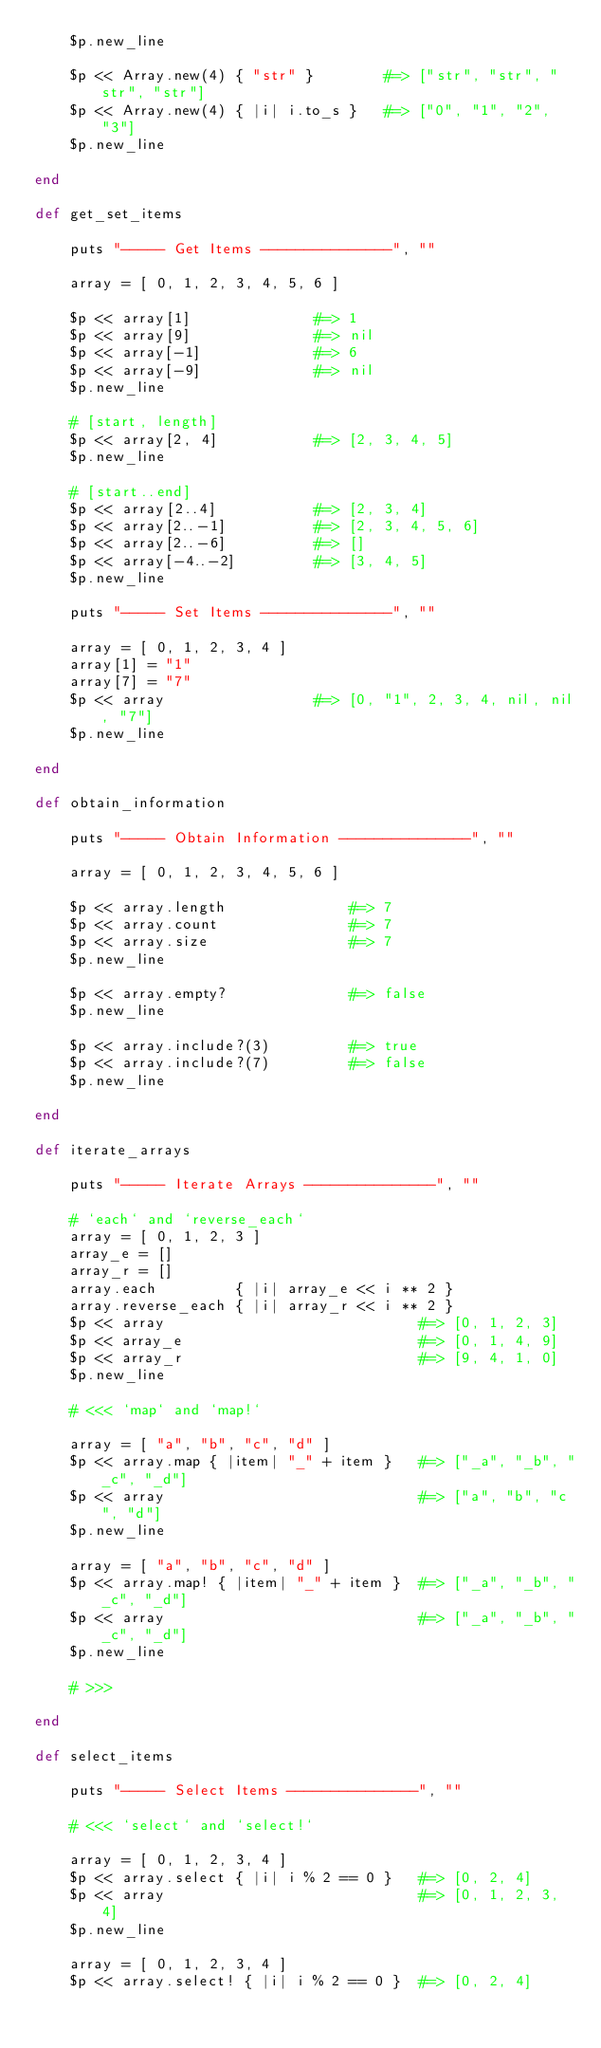<code> <loc_0><loc_0><loc_500><loc_500><_Ruby_>    $p.new_line

    $p << Array.new(4) { "str" }        #=> ["str", "str", "str", "str"]
    $p << Array.new(4) { |i| i.to_s }   #=> ["0", "1", "2", "3"]
    $p.new_line

end

def get_set_items

    puts "----- Get Items ---------------", ""

    array = [ 0, 1, 2, 3, 4, 5, 6 ]
    
    $p << array[1]              #=> 1
    $p << array[9]              #=> nil
    $p << array[-1]             #=> 6
    $p << array[-9]             #=> nil
    $p.new_line

    # [start, length]
    $p << array[2, 4]           #=> [2, 3, 4, 5]
    $p.new_line

    # [start..end]
    $p << array[2..4]           #=> [2, 3, 4]
    $p << array[2..-1]          #=> [2, 3, 4, 5, 6]
    $p << array[2..-6]          #=> []
    $p << array[-4..-2]         #=> [3, 4, 5]
    $p.new_line

    puts "----- Set Items ---------------", ""

    array = [ 0, 1, 2, 3, 4 ]
    array[1] = "1"
    array[7] = "7"
    $p << array                 #=> [0, "1", 2, 3, 4, nil, nil, "7"]
    $p.new_line

end

def obtain_information

    puts "----- Obtain Information ---------------", ""

    array = [ 0, 1, 2, 3, 4, 5, 6 ]

    $p << array.length              #=> 7
    $p << array.count               #=> 7
    $p << array.size                #=> 7
    $p.new_line

    $p << array.empty?              #=> false
    $p.new_line

    $p << array.include?(3)         #=> true
    $p << array.include?(7)         #=> false
    $p.new_line
    
end

def iterate_arrays

    puts "----- Iterate Arrays ---------------", ""

    # `each` and `reverse_each`
    array = [ 0, 1, 2, 3 ]
    array_e = []
    array_r = []
    array.each         { |i| array_e << i ** 2 }
    array.reverse_each { |i| array_r << i ** 2 }
    $p << array                             #=> [0, 1, 2, 3]
    $p << array_e                           #=> [0, 1, 4, 9]
    $p << array_r                           #=> [9, 4, 1, 0]
    $p.new_line

    # <<< `map` and `map!`

    array = [ "a", "b", "c", "d" ]
    $p << array.map { |item| "_" + item }   #=> ["_a", "_b", "_c", "_d"]
    $p << array                             #=> ["a", "b", "c", "d"]
    $p.new_line

    array = [ "a", "b", "c", "d" ]
    $p << array.map! { |item| "_" + item }  #=> ["_a", "_b", "_c", "_d"]
    $p << array                             #=> ["_a", "_b", "_c", "_d"]
    $p.new_line

    # >>>

end

def select_items

    puts "----- Select Items ---------------", ""

    # <<< `select` and `select!`

    array = [ 0, 1, 2, 3, 4 ]
    $p << array.select { |i| i % 2 == 0 }   #=> [0, 2, 4]
    $p << array                             #=> [0, 1, 2, 3, 4]
    $p.new_line

    array = [ 0, 1, 2, 3, 4 ]
    $p << array.select! { |i| i % 2 == 0 }  #=> [0, 2, 4]</code> 